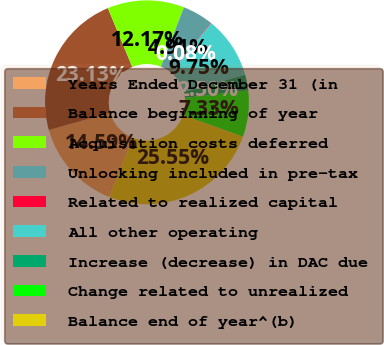Convert chart. <chart><loc_0><loc_0><loc_500><loc_500><pie_chart><fcel>Years Ended December 31 (in<fcel>Balance beginning of year<fcel>Acquisition costs deferred<fcel>Unlocking included in pre-tax<fcel>Related to realized capital<fcel>All other operating<fcel>Increase (decrease) in DAC due<fcel>Change related to unrealized<fcel>Balance end of year^(b)<nl><fcel>14.59%<fcel>23.13%<fcel>12.17%<fcel>4.91%<fcel>0.08%<fcel>9.75%<fcel>2.5%<fcel>7.33%<fcel>25.55%<nl></chart> 